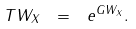Convert formula to latex. <formula><loc_0><loc_0><loc_500><loc_500>T W _ { X } \ = \ e ^ { G W _ { X } } .</formula> 